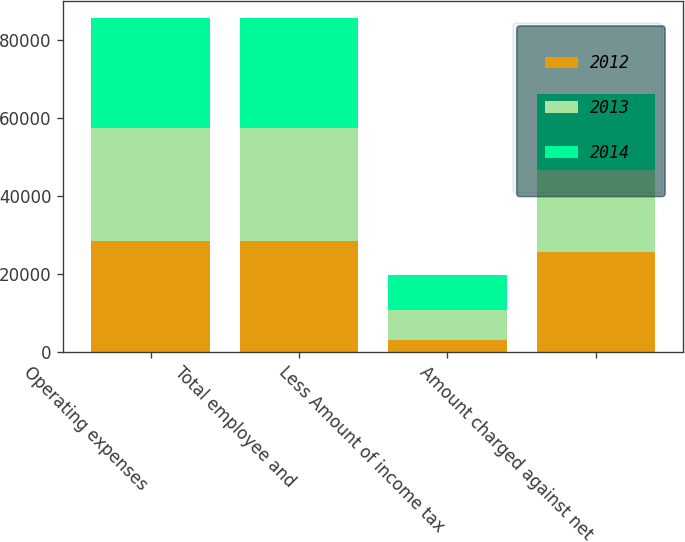Convert chart to OTSL. <chart><loc_0><loc_0><loc_500><loc_500><stacked_bar_chart><ecel><fcel>Operating expenses<fcel>Total employee and<fcel>Less Amount of income tax<fcel>Amount charged against net<nl><fcel>2012<fcel>28552<fcel>28552<fcel>2932<fcel>25620<nl><fcel>2013<fcel>28764<fcel>28764<fcel>7730<fcel>21034<nl><fcel>2014<fcel>28413<fcel>28413<fcel>8933<fcel>19480<nl></chart> 